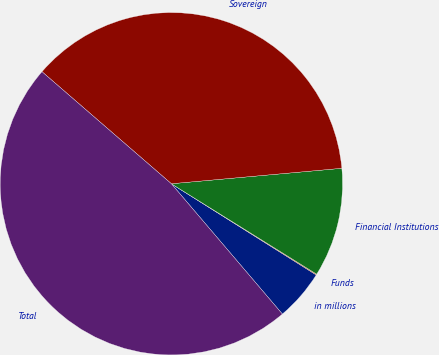Convert chart. <chart><loc_0><loc_0><loc_500><loc_500><pie_chart><fcel>in millions<fcel>Funds<fcel>Financial Institutions<fcel>Sovereign<fcel>Total<nl><fcel>4.83%<fcel>0.08%<fcel>10.3%<fcel>37.2%<fcel>47.59%<nl></chart> 